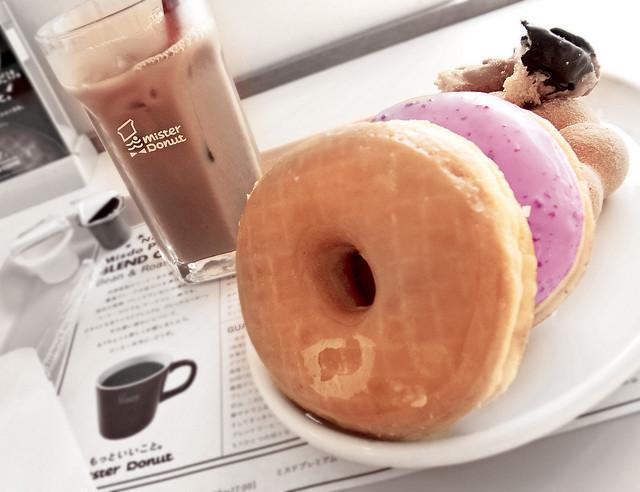How many donuts can you see?
Give a very brief answer. 3. How many cups are in the photo?
Give a very brief answer. 3. How many fins does the surfboard have?
Give a very brief answer. 0. 